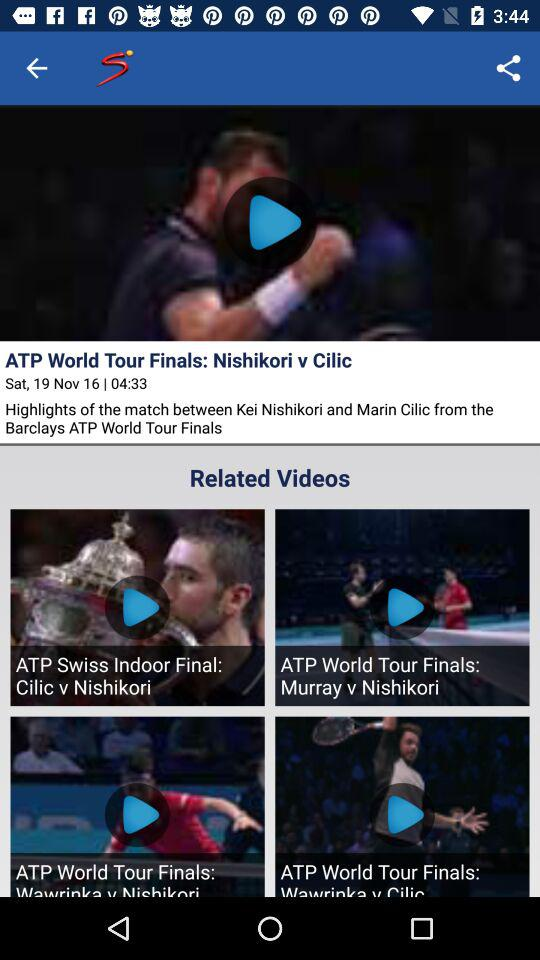What are the players' names who played in the Barclays ATP World Tour finals? The players are "Kei Nishikori" and "Marin Cilic". 